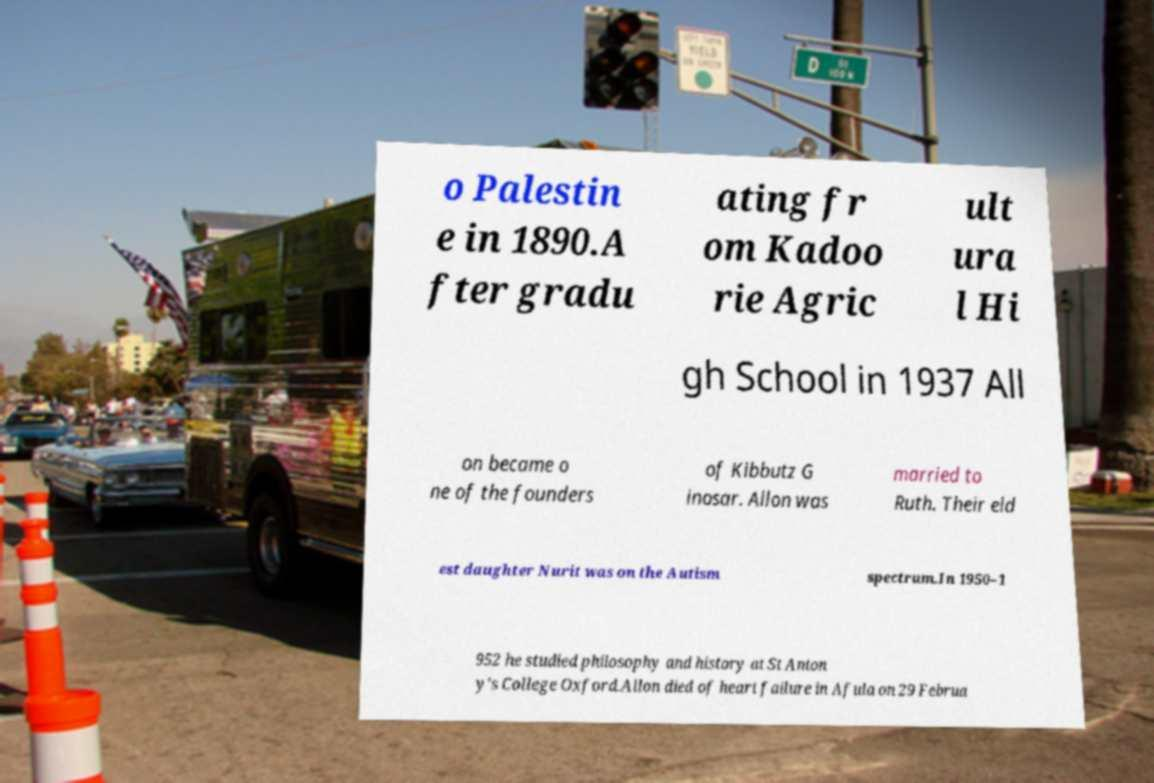I need the written content from this picture converted into text. Can you do that? o Palestin e in 1890.A fter gradu ating fr om Kadoo rie Agric ult ura l Hi gh School in 1937 All on became o ne of the founders of Kibbutz G inosar. Allon was married to Ruth. Their eld est daughter Nurit was on the Autism spectrum.In 1950–1 952 he studied philosophy and history at St Anton y's College Oxford.Allon died of heart failure in Afula on 29 Februa 